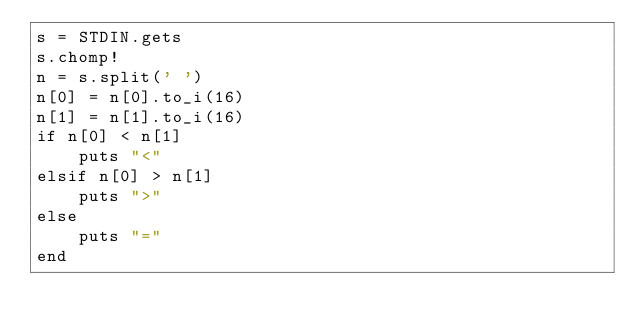<code> <loc_0><loc_0><loc_500><loc_500><_Ruby_>s = STDIN.gets
s.chomp!
n = s.split(' ')
n[0] = n[0].to_i(16)
n[1] = n[1].to_i(16)
if n[0] < n[1]
	puts "<"
elsif n[0] > n[1]
	puts ">"
else
	puts "="
end
</code> 